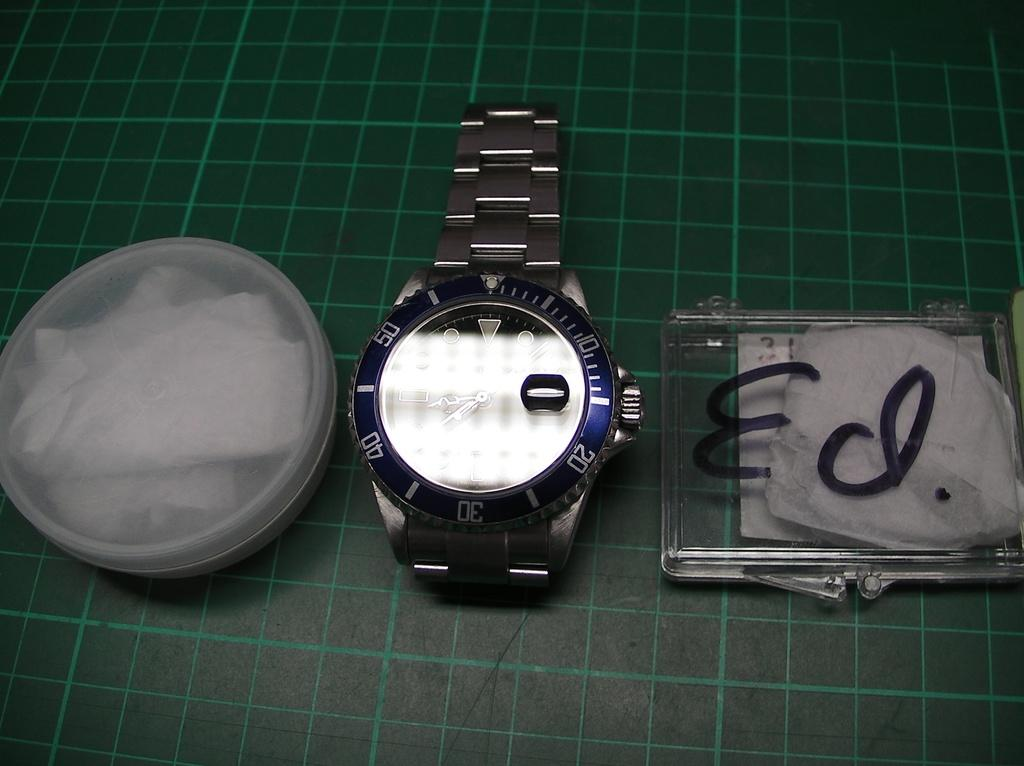<image>
Create a compact narrative representing the image presented. A clear box that says "Ed." is next to a watch. 